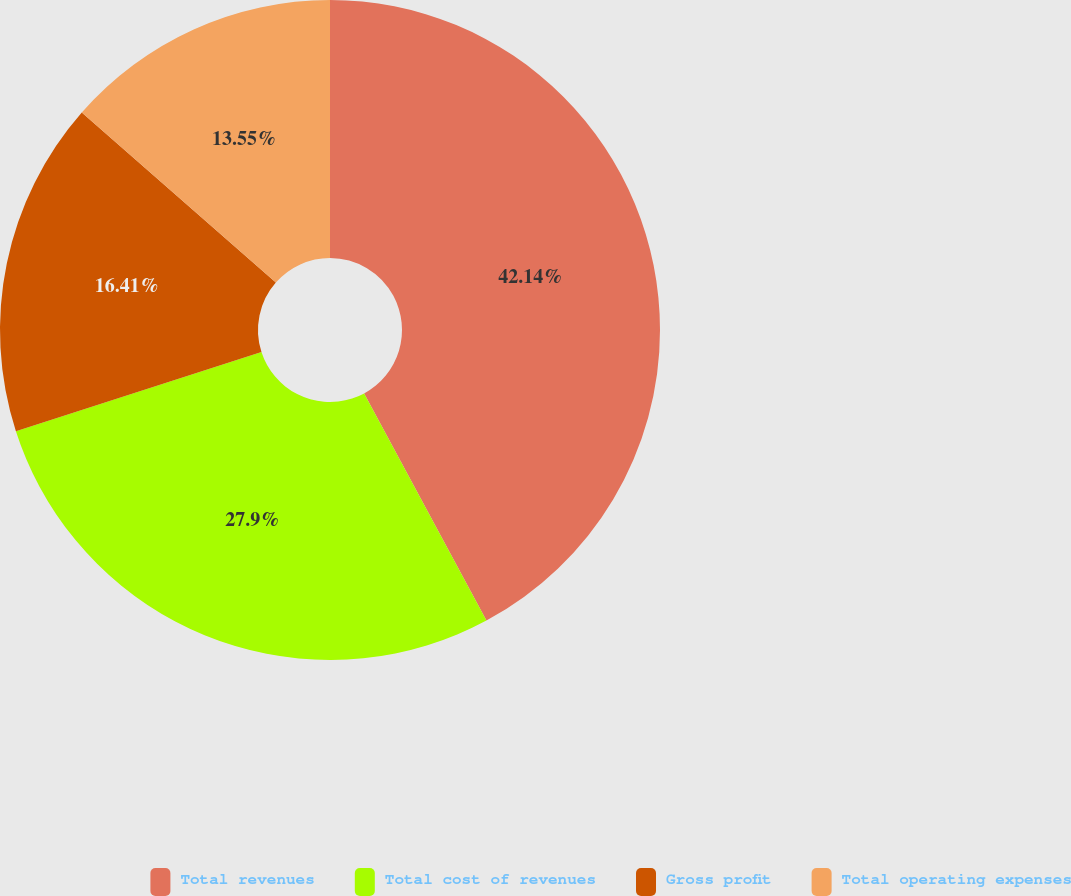<chart> <loc_0><loc_0><loc_500><loc_500><pie_chart><fcel>Total revenues<fcel>Total cost of revenues<fcel>Gross profit<fcel>Total operating expenses<nl><fcel>42.14%<fcel>27.9%<fcel>16.41%<fcel>13.55%<nl></chart> 